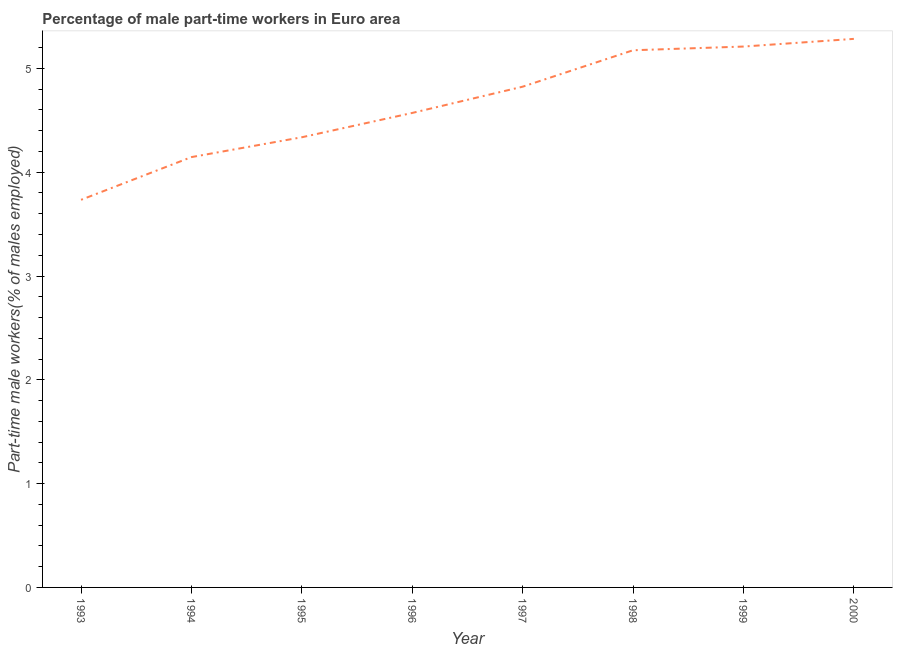What is the percentage of part-time male workers in 1996?
Your response must be concise. 4.57. Across all years, what is the maximum percentage of part-time male workers?
Give a very brief answer. 5.28. Across all years, what is the minimum percentage of part-time male workers?
Your answer should be very brief. 3.73. In which year was the percentage of part-time male workers maximum?
Keep it short and to the point. 2000. In which year was the percentage of part-time male workers minimum?
Your response must be concise. 1993. What is the sum of the percentage of part-time male workers?
Give a very brief answer. 37.28. What is the difference between the percentage of part-time male workers in 1995 and 1997?
Offer a very short reply. -0.49. What is the average percentage of part-time male workers per year?
Your answer should be compact. 4.66. What is the median percentage of part-time male workers?
Your answer should be very brief. 4.7. In how many years, is the percentage of part-time male workers greater than 2.2 %?
Offer a very short reply. 8. Do a majority of the years between 1997 and 2000 (inclusive) have percentage of part-time male workers greater than 0.6000000000000001 %?
Offer a terse response. Yes. What is the ratio of the percentage of part-time male workers in 1995 to that in 1998?
Ensure brevity in your answer.  0.84. Is the difference between the percentage of part-time male workers in 1997 and 2000 greater than the difference between any two years?
Ensure brevity in your answer.  No. What is the difference between the highest and the second highest percentage of part-time male workers?
Your answer should be very brief. 0.07. Is the sum of the percentage of part-time male workers in 1995 and 1998 greater than the maximum percentage of part-time male workers across all years?
Make the answer very short. Yes. What is the difference between the highest and the lowest percentage of part-time male workers?
Offer a very short reply. 1.55. Does the percentage of part-time male workers monotonically increase over the years?
Keep it short and to the point. Yes. How many years are there in the graph?
Your response must be concise. 8. What is the difference between two consecutive major ticks on the Y-axis?
Give a very brief answer. 1. Does the graph contain any zero values?
Give a very brief answer. No. Does the graph contain grids?
Your answer should be very brief. No. What is the title of the graph?
Your response must be concise. Percentage of male part-time workers in Euro area. What is the label or title of the X-axis?
Give a very brief answer. Year. What is the label or title of the Y-axis?
Give a very brief answer. Part-time male workers(% of males employed). What is the Part-time male workers(% of males employed) in 1993?
Offer a very short reply. 3.73. What is the Part-time male workers(% of males employed) of 1994?
Your answer should be compact. 4.15. What is the Part-time male workers(% of males employed) of 1995?
Offer a very short reply. 4.34. What is the Part-time male workers(% of males employed) of 1996?
Your answer should be compact. 4.57. What is the Part-time male workers(% of males employed) of 1997?
Provide a succinct answer. 4.82. What is the Part-time male workers(% of males employed) in 1998?
Your answer should be very brief. 5.17. What is the Part-time male workers(% of males employed) in 1999?
Provide a succinct answer. 5.21. What is the Part-time male workers(% of males employed) in 2000?
Your answer should be compact. 5.28. What is the difference between the Part-time male workers(% of males employed) in 1993 and 1994?
Offer a terse response. -0.41. What is the difference between the Part-time male workers(% of males employed) in 1993 and 1995?
Ensure brevity in your answer.  -0.6. What is the difference between the Part-time male workers(% of males employed) in 1993 and 1996?
Give a very brief answer. -0.84. What is the difference between the Part-time male workers(% of males employed) in 1993 and 1997?
Offer a terse response. -1.09. What is the difference between the Part-time male workers(% of males employed) in 1993 and 1998?
Your answer should be very brief. -1.44. What is the difference between the Part-time male workers(% of males employed) in 1993 and 1999?
Your answer should be very brief. -1.48. What is the difference between the Part-time male workers(% of males employed) in 1993 and 2000?
Provide a short and direct response. -1.55. What is the difference between the Part-time male workers(% of males employed) in 1994 and 1995?
Ensure brevity in your answer.  -0.19. What is the difference between the Part-time male workers(% of males employed) in 1994 and 1996?
Offer a very short reply. -0.43. What is the difference between the Part-time male workers(% of males employed) in 1994 and 1997?
Provide a short and direct response. -0.68. What is the difference between the Part-time male workers(% of males employed) in 1994 and 1998?
Ensure brevity in your answer.  -1.03. What is the difference between the Part-time male workers(% of males employed) in 1994 and 1999?
Your response must be concise. -1.06. What is the difference between the Part-time male workers(% of males employed) in 1994 and 2000?
Offer a terse response. -1.14. What is the difference between the Part-time male workers(% of males employed) in 1995 and 1996?
Your response must be concise. -0.23. What is the difference between the Part-time male workers(% of males employed) in 1995 and 1997?
Your answer should be compact. -0.49. What is the difference between the Part-time male workers(% of males employed) in 1995 and 1998?
Give a very brief answer. -0.84. What is the difference between the Part-time male workers(% of males employed) in 1995 and 1999?
Make the answer very short. -0.87. What is the difference between the Part-time male workers(% of males employed) in 1995 and 2000?
Ensure brevity in your answer.  -0.95. What is the difference between the Part-time male workers(% of males employed) in 1996 and 1997?
Your answer should be compact. -0.25. What is the difference between the Part-time male workers(% of males employed) in 1996 and 1998?
Keep it short and to the point. -0.6. What is the difference between the Part-time male workers(% of males employed) in 1996 and 1999?
Provide a short and direct response. -0.64. What is the difference between the Part-time male workers(% of males employed) in 1996 and 2000?
Your answer should be compact. -0.71. What is the difference between the Part-time male workers(% of males employed) in 1997 and 1998?
Ensure brevity in your answer.  -0.35. What is the difference between the Part-time male workers(% of males employed) in 1997 and 1999?
Your response must be concise. -0.39. What is the difference between the Part-time male workers(% of males employed) in 1997 and 2000?
Keep it short and to the point. -0.46. What is the difference between the Part-time male workers(% of males employed) in 1998 and 1999?
Your response must be concise. -0.04. What is the difference between the Part-time male workers(% of males employed) in 1998 and 2000?
Provide a succinct answer. -0.11. What is the difference between the Part-time male workers(% of males employed) in 1999 and 2000?
Keep it short and to the point. -0.07. What is the ratio of the Part-time male workers(% of males employed) in 1993 to that in 1994?
Offer a very short reply. 0.9. What is the ratio of the Part-time male workers(% of males employed) in 1993 to that in 1995?
Offer a terse response. 0.86. What is the ratio of the Part-time male workers(% of males employed) in 1993 to that in 1996?
Ensure brevity in your answer.  0.82. What is the ratio of the Part-time male workers(% of males employed) in 1993 to that in 1997?
Give a very brief answer. 0.77. What is the ratio of the Part-time male workers(% of males employed) in 1993 to that in 1998?
Offer a very short reply. 0.72. What is the ratio of the Part-time male workers(% of males employed) in 1993 to that in 1999?
Keep it short and to the point. 0.72. What is the ratio of the Part-time male workers(% of males employed) in 1993 to that in 2000?
Your answer should be compact. 0.71. What is the ratio of the Part-time male workers(% of males employed) in 1994 to that in 1995?
Offer a very short reply. 0.96. What is the ratio of the Part-time male workers(% of males employed) in 1994 to that in 1996?
Your answer should be very brief. 0.91. What is the ratio of the Part-time male workers(% of males employed) in 1994 to that in 1997?
Offer a very short reply. 0.86. What is the ratio of the Part-time male workers(% of males employed) in 1994 to that in 1998?
Your answer should be compact. 0.8. What is the ratio of the Part-time male workers(% of males employed) in 1994 to that in 1999?
Make the answer very short. 0.8. What is the ratio of the Part-time male workers(% of males employed) in 1994 to that in 2000?
Ensure brevity in your answer.  0.78. What is the ratio of the Part-time male workers(% of males employed) in 1995 to that in 1996?
Provide a succinct answer. 0.95. What is the ratio of the Part-time male workers(% of males employed) in 1995 to that in 1997?
Make the answer very short. 0.9. What is the ratio of the Part-time male workers(% of males employed) in 1995 to that in 1998?
Provide a short and direct response. 0.84. What is the ratio of the Part-time male workers(% of males employed) in 1995 to that in 1999?
Keep it short and to the point. 0.83. What is the ratio of the Part-time male workers(% of males employed) in 1995 to that in 2000?
Your answer should be compact. 0.82. What is the ratio of the Part-time male workers(% of males employed) in 1996 to that in 1997?
Your answer should be very brief. 0.95. What is the ratio of the Part-time male workers(% of males employed) in 1996 to that in 1998?
Your answer should be compact. 0.88. What is the ratio of the Part-time male workers(% of males employed) in 1996 to that in 1999?
Give a very brief answer. 0.88. What is the ratio of the Part-time male workers(% of males employed) in 1996 to that in 2000?
Your answer should be compact. 0.86. What is the ratio of the Part-time male workers(% of males employed) in 1997 to that in 1998?
Ensure brevity in your answer.  0.93. What is the ratio of the Part-time male workers(% of males employed) in 1997 to that in 1999?
Offer a terse response. 0.93. What is the ratio of the Part-time male workers(% of males employed) in 1997 to that in 2000?
Provide a succinct answer. 0.91. What is the ratio of the Part-time male workers(% of males employed) in 1998 to that in 2000?
Offer a very short reply. 0.98. What is the ratio of the Part-time male workers(% of males employed) in 1999 to that in 2000?
Your answer should be very brief. 0.99. 